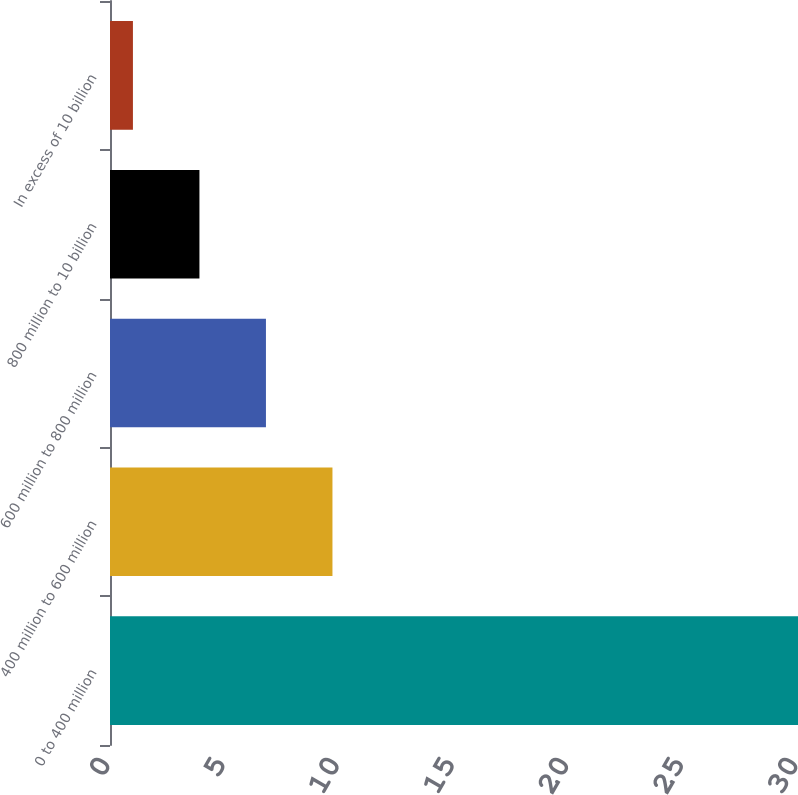Convert chart. <chart><loc_0><loc_0><loc_500><loc_500><bar_chart><fcel>0 to 400 million<fcel>400 million to 600 million<fcel>600 million to 800 million<fcel>800 million to 10 billion<fcel>In excess of 10 billion<nl><fcel>30<fcel>9.7<fcel>6.8<fcel>3.9<fcel>1<nl></chart> 